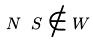<formula> <loc_0><loc_0><loc_500><loc_500>N \ S \notin W</formula> 